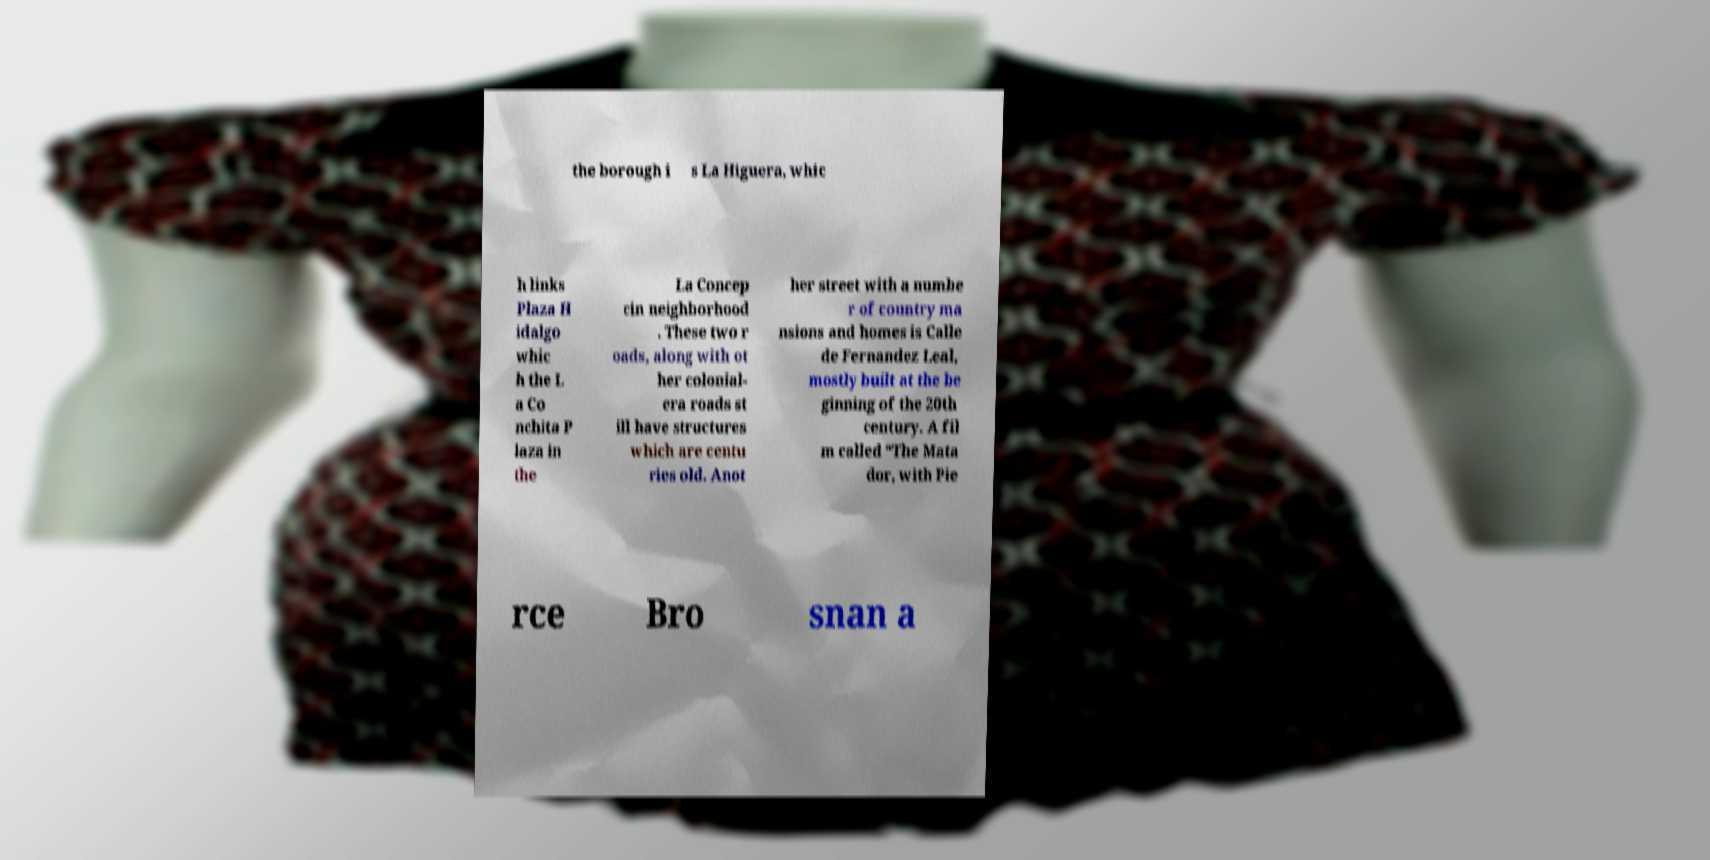Can you read and provide the text displayed in the image?This photo seems to have some interesting text. Can you extract and type it out for me? the borough i s La Higuera, whic h links Plaza H idalgo whic h the L a Co nchita P laza in the La Concep cin neighborhood . These two r oads, along with ot her colonial- era roads st ill have structures which are centu ries old. Anot her street with a numbe r of country ma nsions and homes is Calle de Fernandez Leal, mostly built at the be ginning of the 20th century. A fil m called “The Mata dor, with Pie rce Bro snan a 